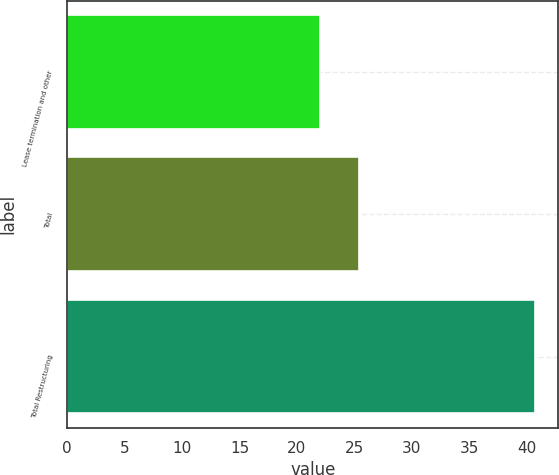<chart> <loc_0><loc_0><loc_500><loc_500><bar_chart><fcel>Lease termination and other<fcel>Total<fcel>Total Restructuring<nl><fcel>22<fcel>25.4<fcel>40.7<nl></chart> 